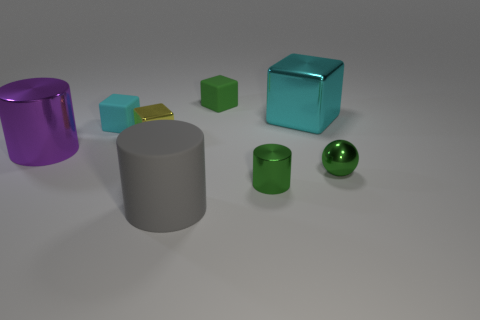Subtract all purple cylinders. Subtract all brown cubes. How many cylinders are left? 2 Add 2 big blocks. How many objects exist? 10 Subtract all spheres. How many objects are left? 7 Add 2 purple cylinders. How many purple cylinders exist? 3 Subtract 2 cyan blocks. How many objects are left? 6 Subtract all brown rubber spheres. Subtract all tiny matte objects. How many objects are left? 6 Add 7 small green shiny balls. How many small green shiny balls are left? 8 